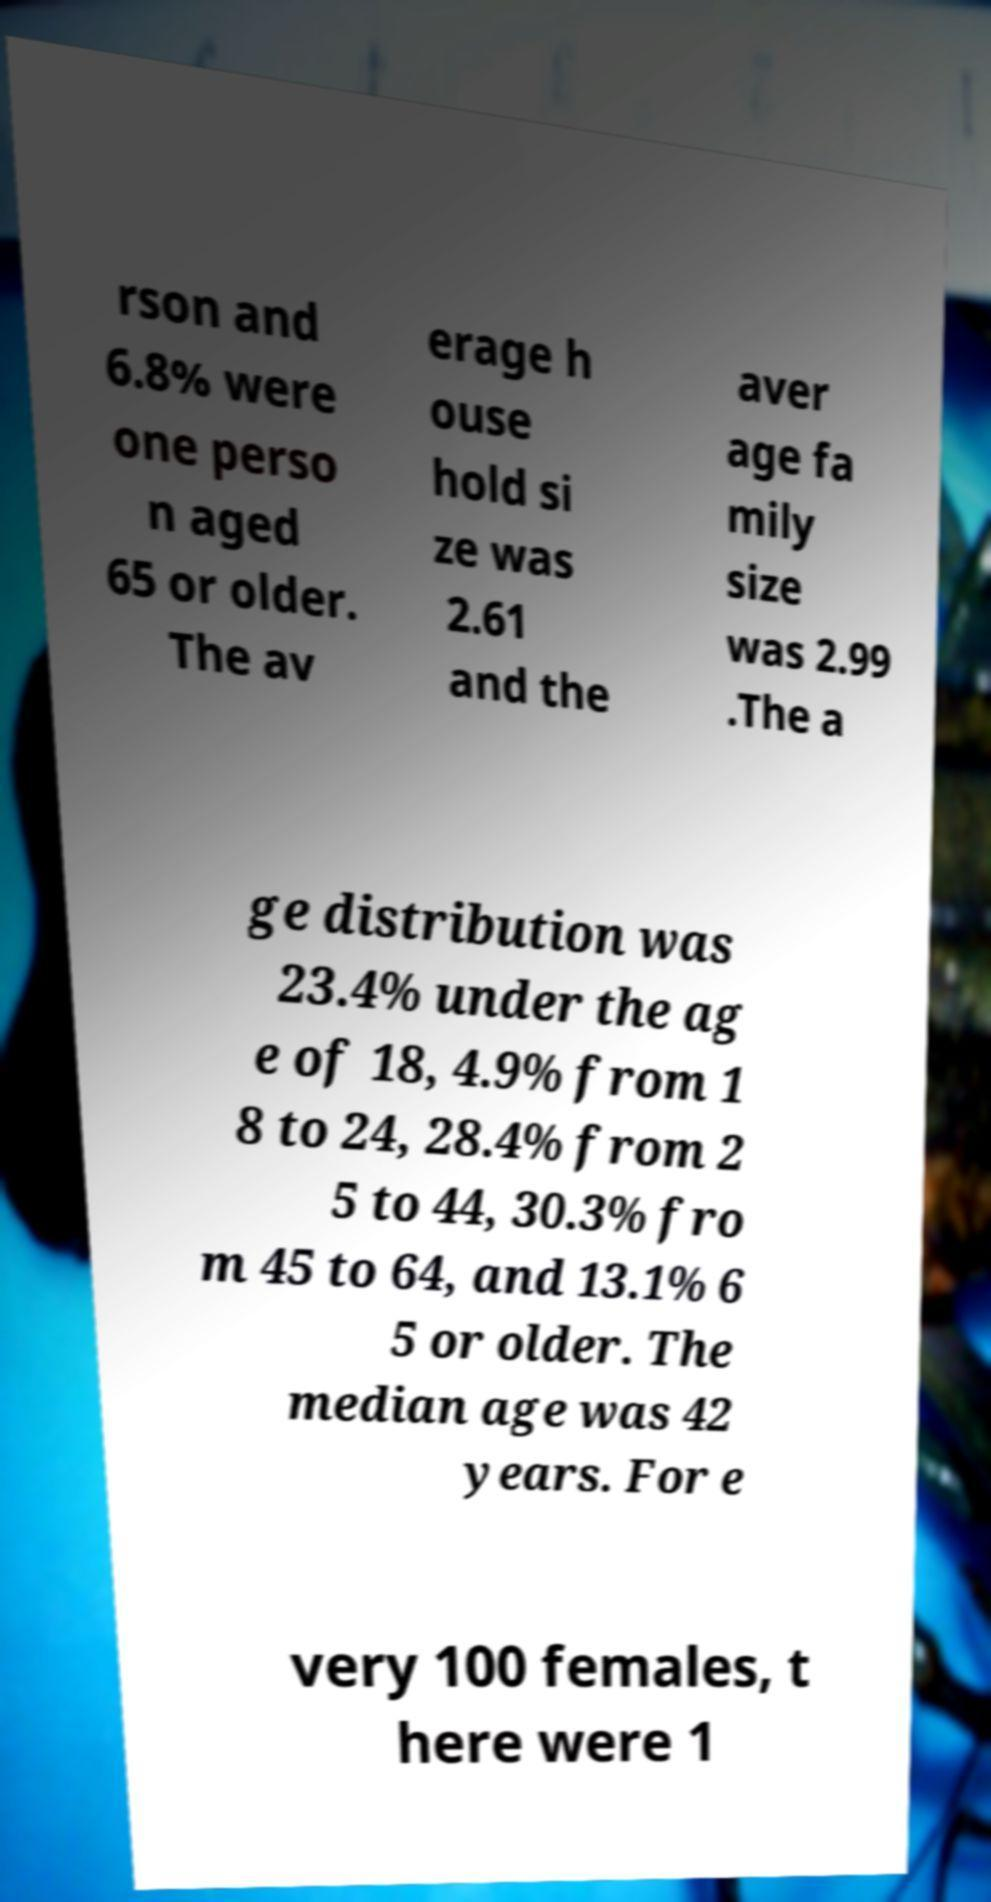Please identify and transcribe the text found in this image. rson and 6.8% were one perso n aged 65 or older. The av erage h ouse hold si ze was 2.61 and the aver age fa mily size was 2.99 .The a ge distribution was 23.4% under the ag e of 18, 4.9% from 1 8 to 24, 28.4% from 2 5 to 44, 30.3% fro m 45 to 64, and 13.1% 6 5 or older. The median age was 42 years. For e very 100 females, t here were 1 